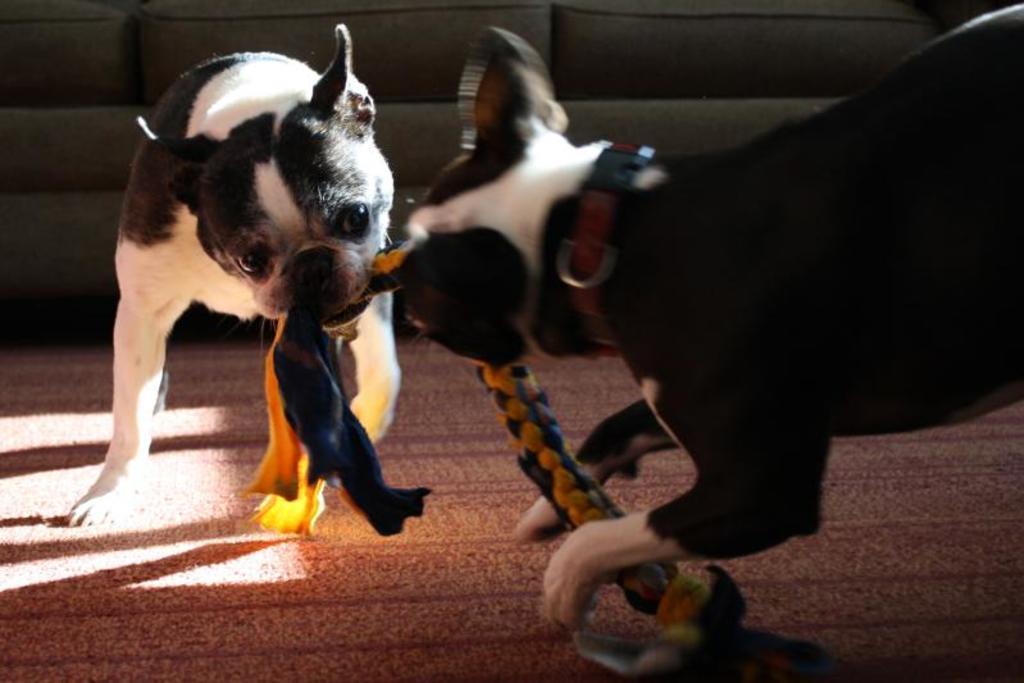Can you describe this image briefly? In this image there are two dogs, there is an object in the mouth of the dogs, there is carpet on the floor towards the bottom of the image, there is a couch towards the top of the image. 